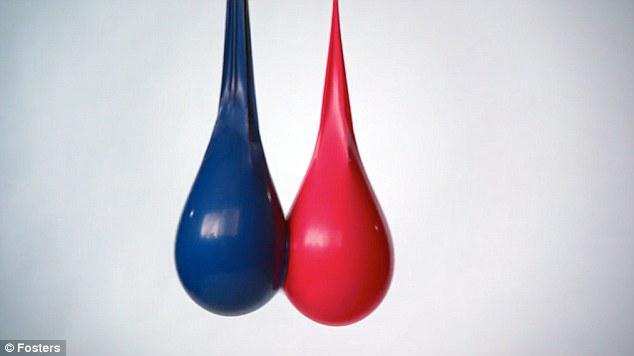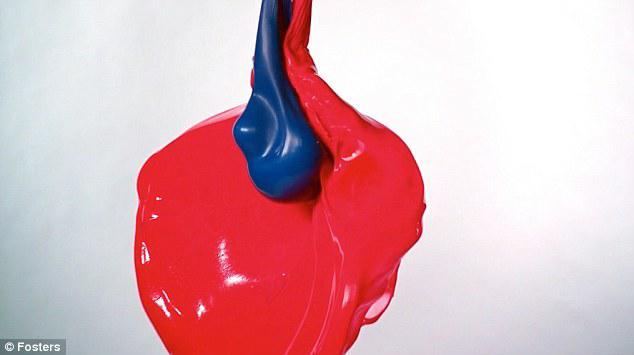The first image is the image on the left, the second image is the image on the right. Examine the images to the left and right. Is the description "There is a red and a blue balloon, and also some red and blue goop connected to each other." accurate? Answer yes or no. Yes. The first image is the image on the left, the second image is the image on the right. Assess this claim about the two images: "Exactly one image shows liquid-like side-by-side drops of blue and red.". Correct or not? Answer yes or no. No. 